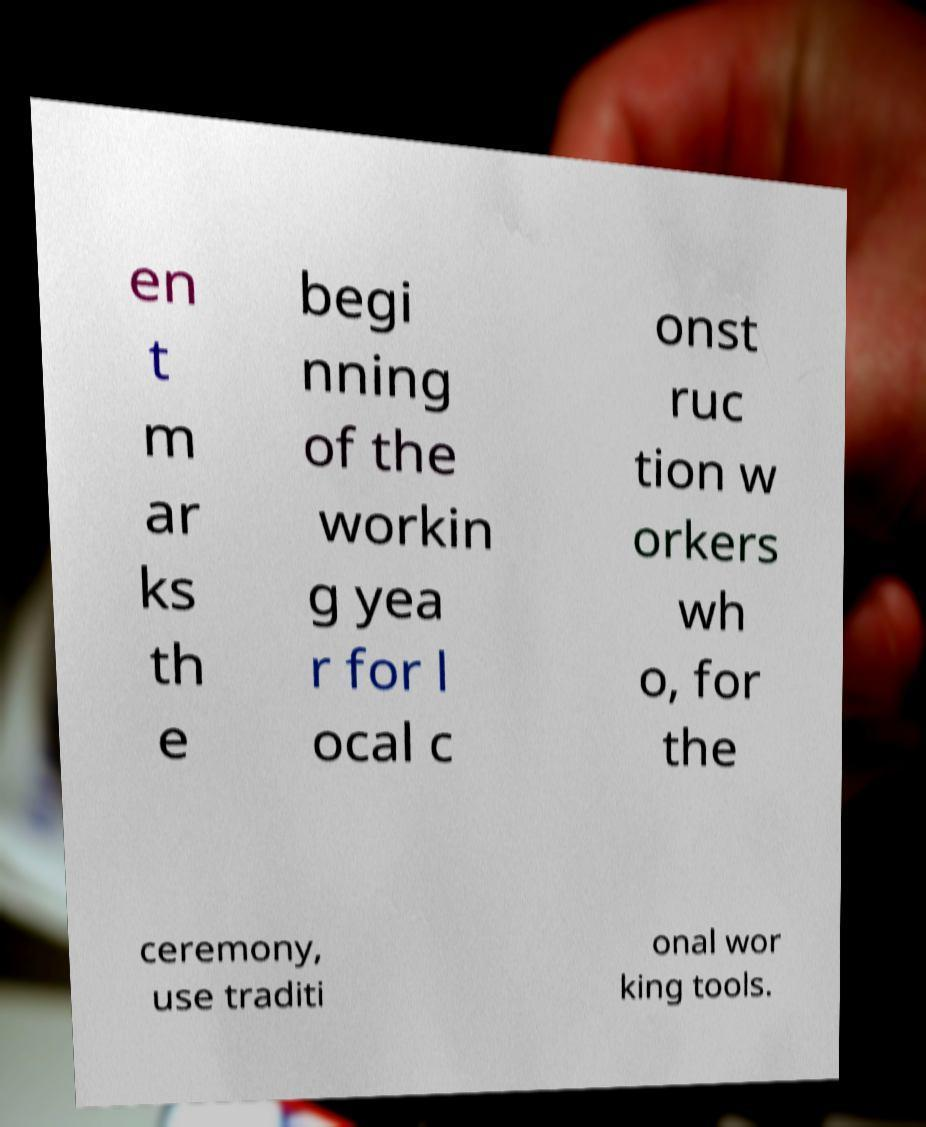For documentation purposes, I need the text within this image transcribed. Could you provide that? en t m ar ks th e begi nning of the workin g yea r for l ocal c onst ruc tion w orkers wh o, for the ceremony, use traditi onal wor king tools. 